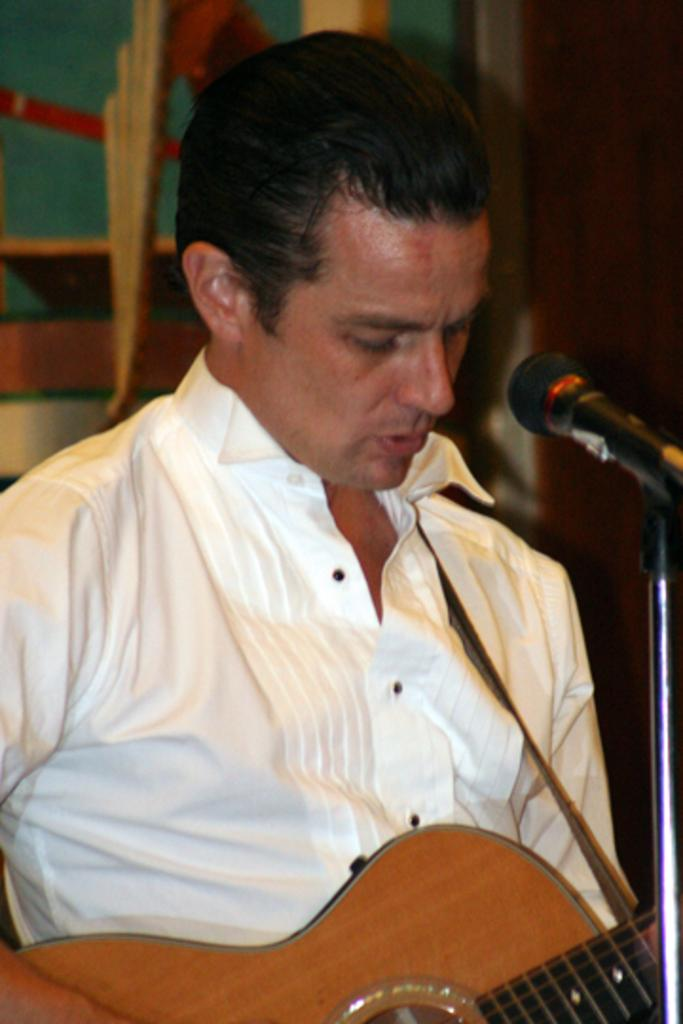What is the man in the image doing? The man is playing a guitar in the image. How is the guitar being used by the man? The guitar is in the man's hands in the image. What object is present in the image that is typically used for amplifying sound? There is a microphone in the image. Where is the man positioned in relation to the microphone? The man is standing in front of the microphone in the image. What type of key is the man using to play the guitar in the image? There is no key present in the image; the man is playing the guitar with his hands. How does the man shake the sleet off his guitar in the image? There is no sleet present in the image, and the man is not shaking anything off his guitar. 